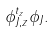<formula> <loc_0><loc_0><loc_500><loc_500>\phi _ { J , z } ^ { t _ { z } } \phi _ { J } .</formula> 